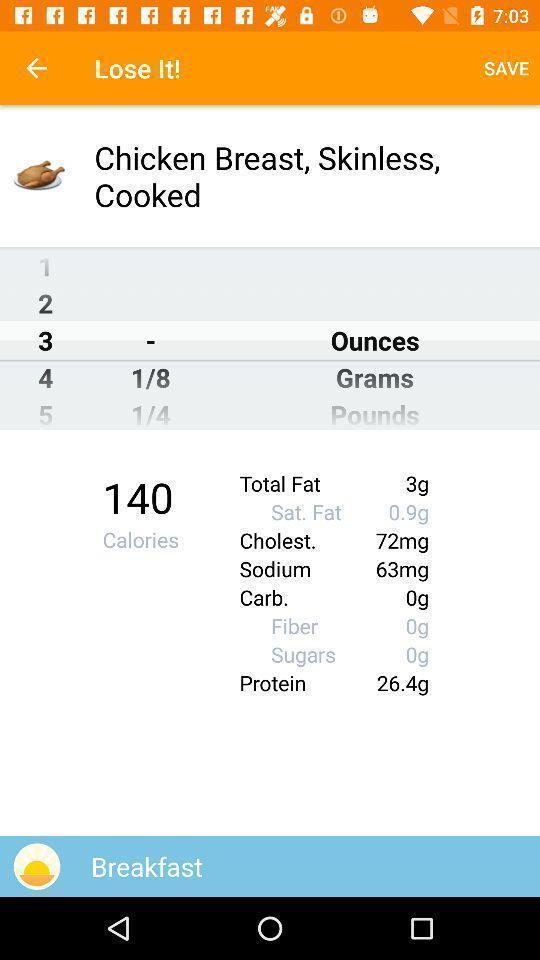Give me a narrative description of this picture. Screen shows the track of food to lose weight. 